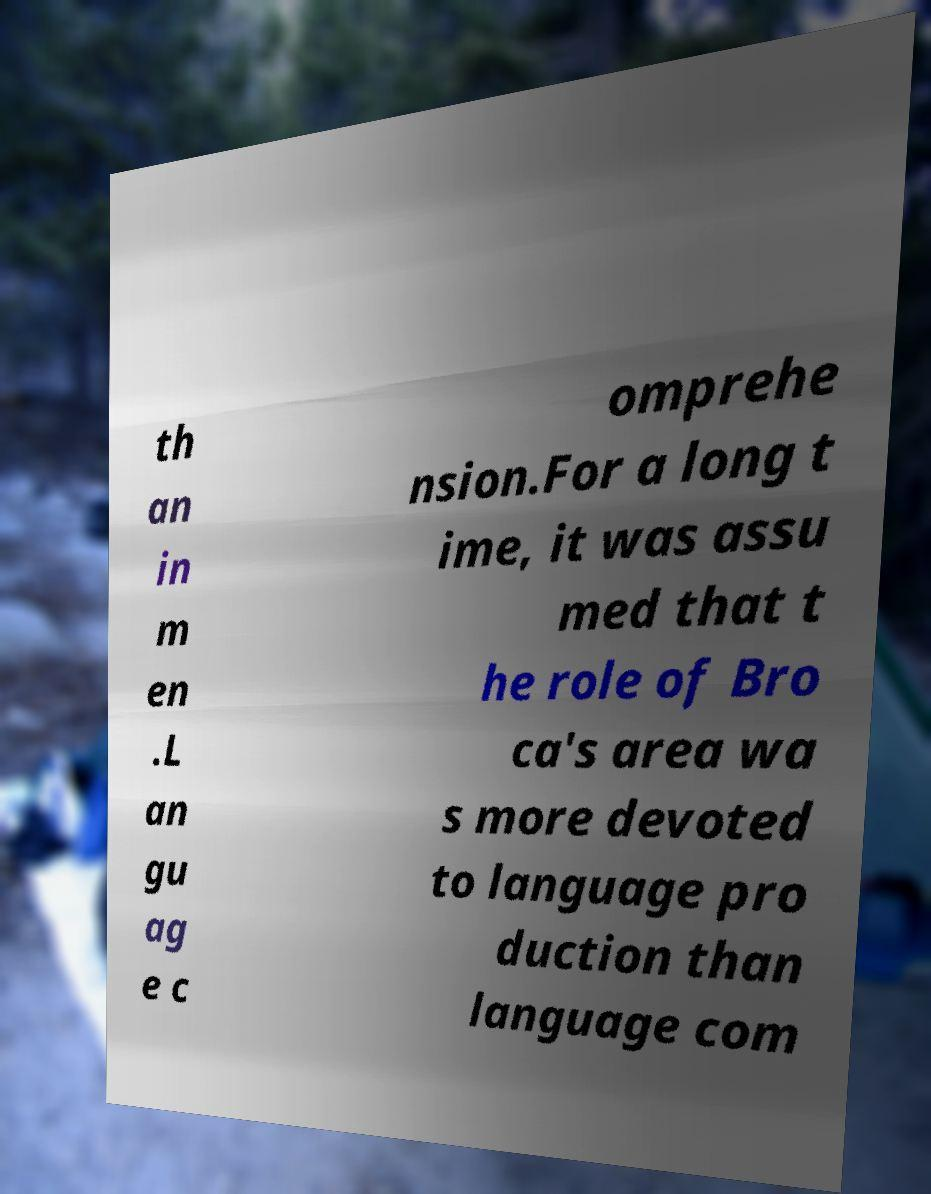I need the written content from this picture converted into text. Can you do that? th an in m en .L an gu ag e c omprehe nsion.For a long t ime, it was assu med that t he role of Bro ca's area wa s more devoted to language pro duction than language com 